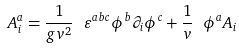Convert formula to latex. <formula><loc_0><loc_0><loc_500><loc_500>A ^ { a } _ { i } = \frac { 1 } { g v ^ { 2 } } \ \varepsilon ^ { a b c } \phi ^ { b } \partial _ { i } \phi ^ { c } + \frac { 1 } { v } \ \phi ^ { a } A _ { i }</formula> 